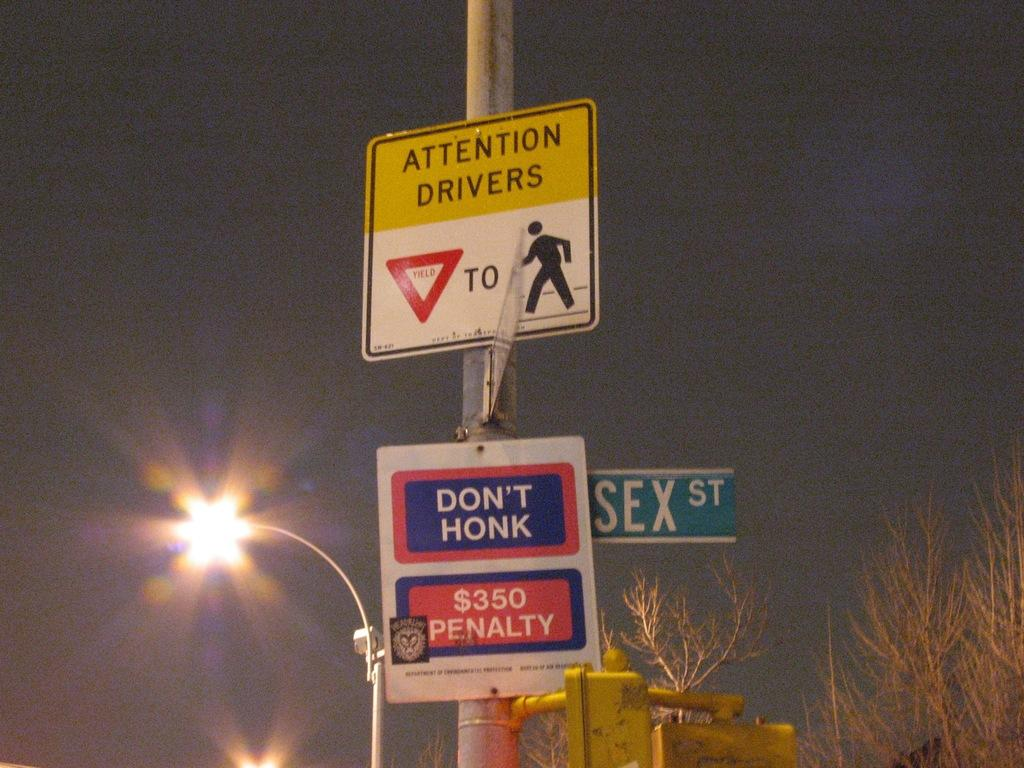What is attached to the pole in the image? There are boards attached to a pole in the image. What can be seen in the background of the image? There are trees visible in the image. What is the purpose of the light on the pole? The light on the pole is likely for illumination purposes. How many times did the mother kiss her child during the week in the image? There is no mother or child present in the image, and therefore no such activity can be observed. 